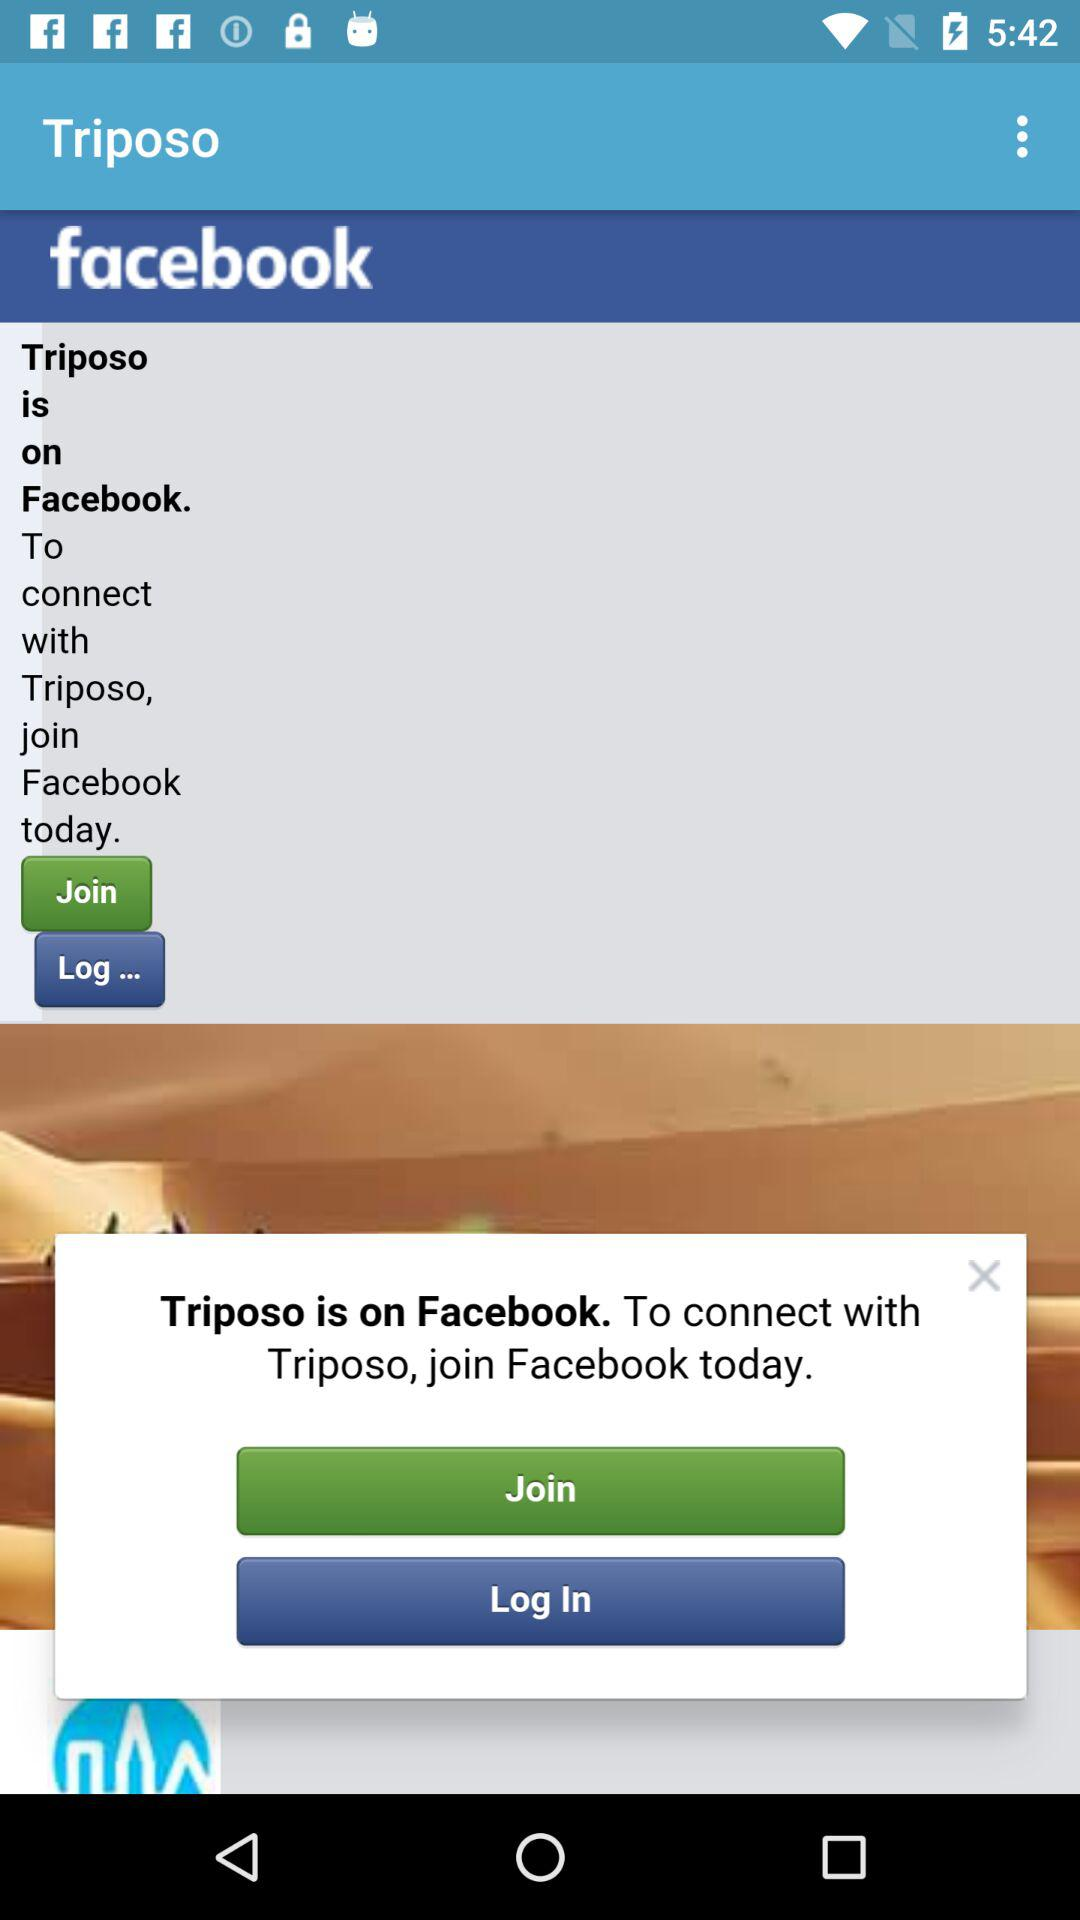How can we connect with "Triposo"? You can connect with "Triposo" by joining "Facebook". 